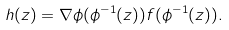Convert formula to latex. <formula><loc_0><loc_0><loc_500><loc_500>h ( z ) = \nabla \phi ( \phi ^ { - 1 } ( z ) ) f ( \phi ^ { - 1 } ( z ) ) .</formula> 